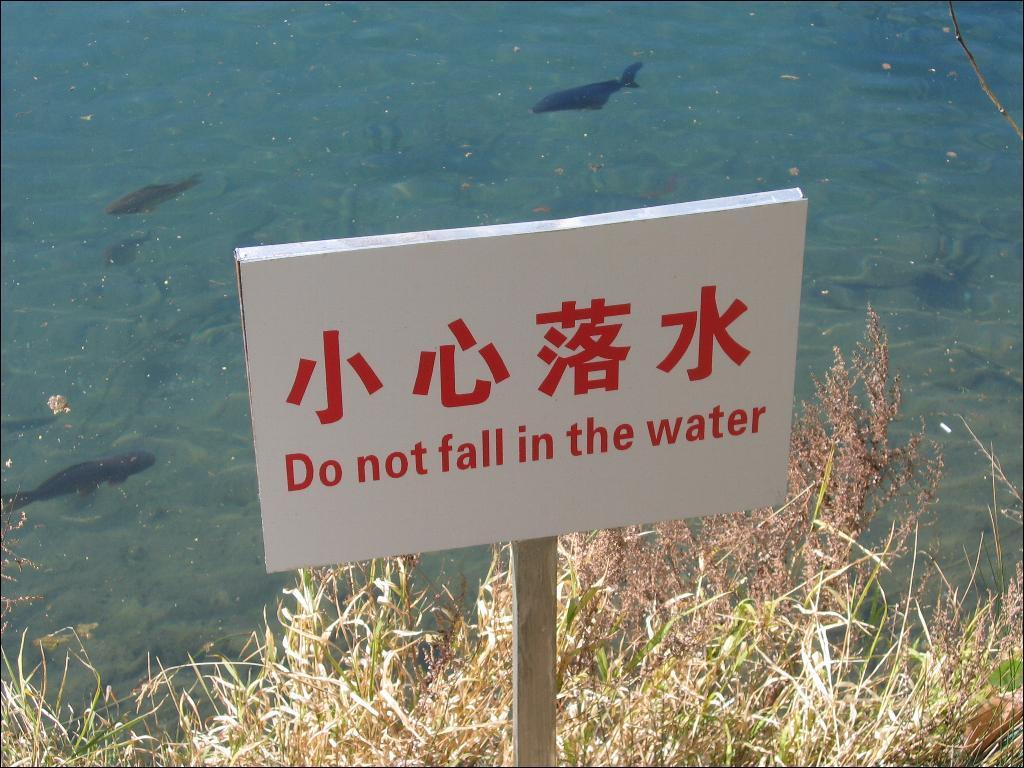What object is attached to a wooden stick in the image? There is a board attached to a wooden stick in the image. What type of terrain is visible at the bottom of the image? Grass is visible at the bottom of the image. What can be seen in the water in the background of the image? There are many fish in the water in the background of the image. How many bricks are stacked on top of each other in the image? There are no bricks present in the image. What causes the fish to fall from the water in the image? The image does not depict any fish falling from the water, and there is no reason for them to do so. 